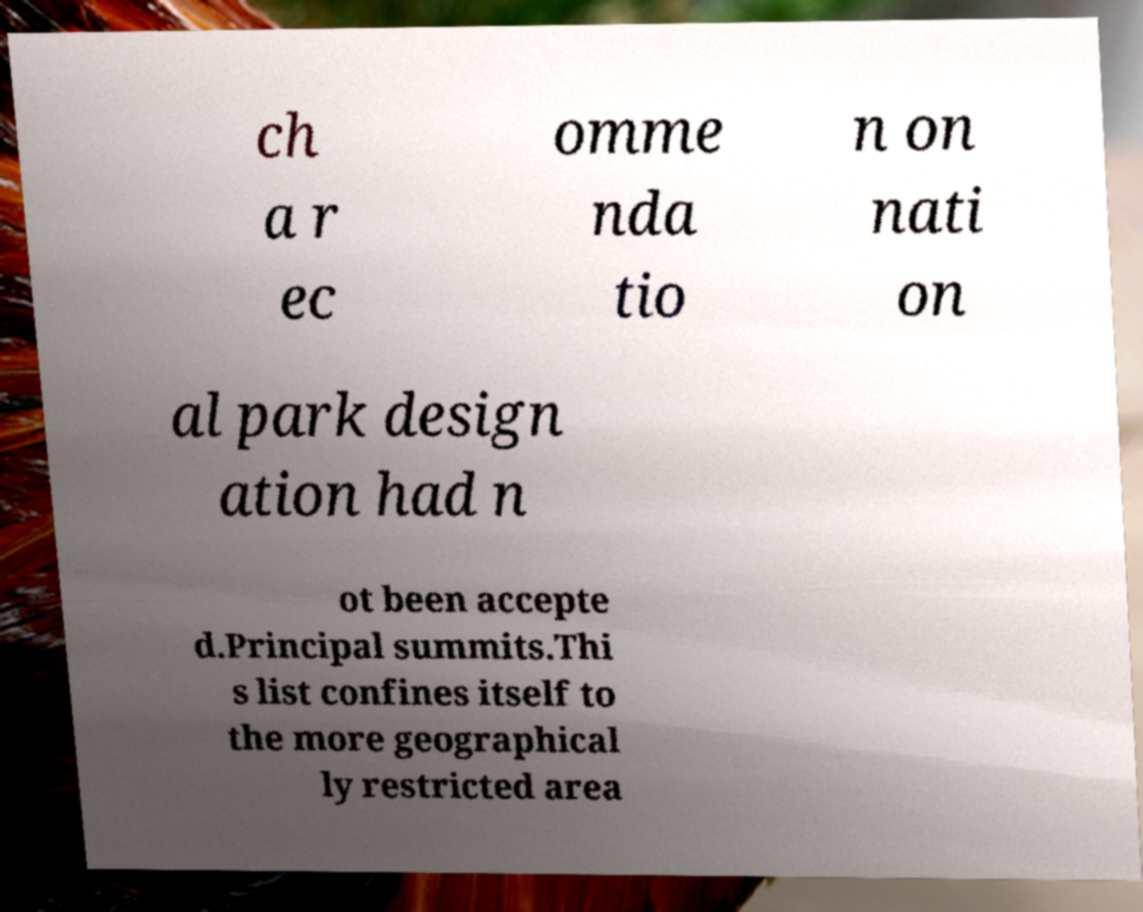I need the written content from this picture converted into text. Can you do that? ch a r ec omme nda tio n on nati on al park design ation had n ot been accepte d.Principal summits.Thi s list confines itself to the more geographical ly restricted area 